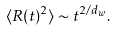Convert formula to latex. <formula><loc_0><loc_0><loc_500><loc_500>\langle { R } ( t ) ^ { 2 } \rangle \sim t ^ { 2 / d _ { w } } .</formula> 